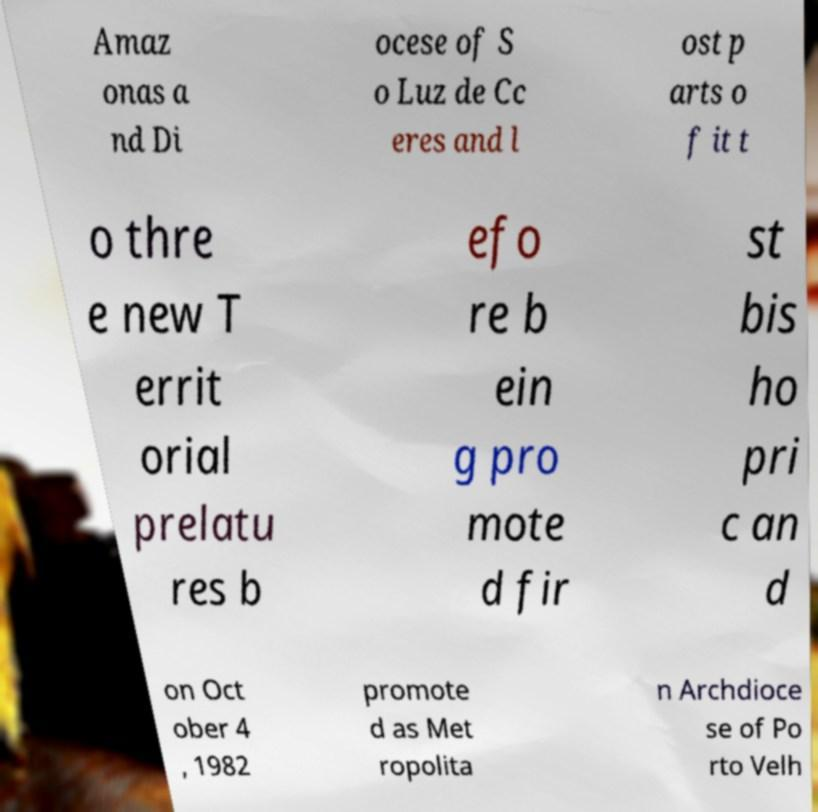Can you accurately transcribe the text from the provided image for me? Amaz onas a nd Di ocese of S o Luz de Cc eres and l ost p arts o f it t o thre e new T errit orial prelatu res b efo re b ein g pro mote d fir st bis ho pri c an d on Oct ober 4 , 1982 promote d as Met ropolita n Archdioce se of Po rto Velh 